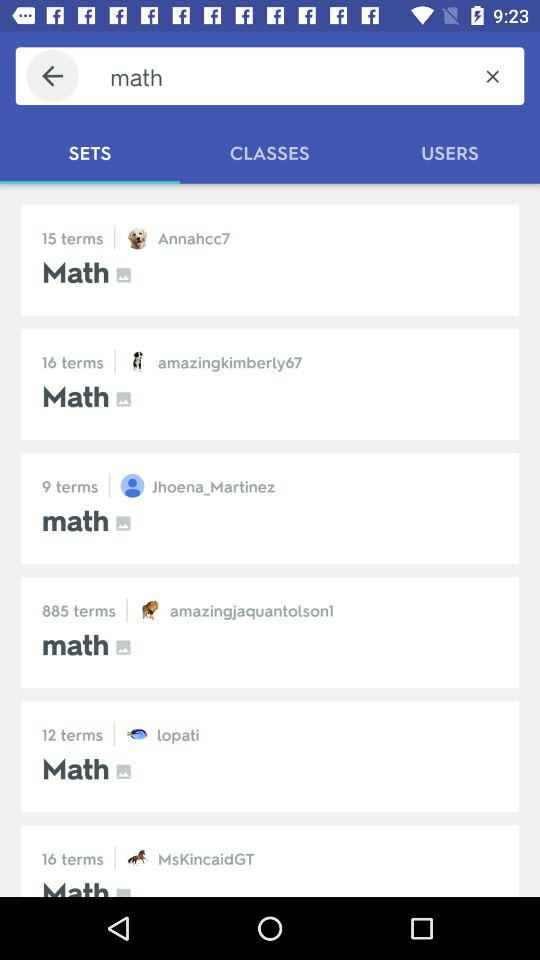Lopati belongs to what term? Lotati belongs to 12 term. 